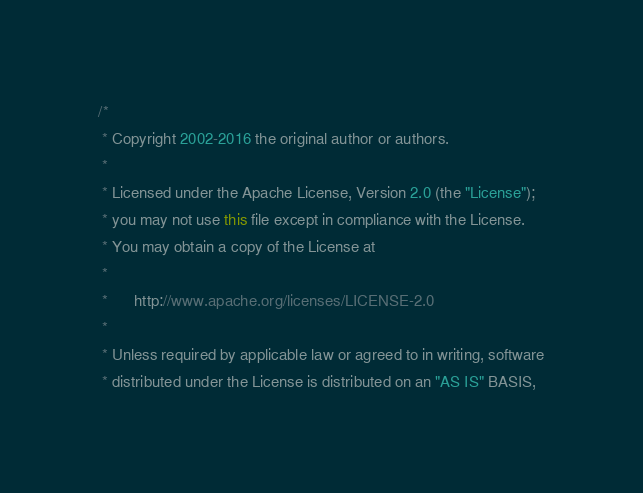Convert code to text. <code><loc_0><loc_0><loc_500><loc_500><_Java_>/*
 * Copyright 2002-2016 the original author or authors.
 *
 * Licensed under the Apache License, Version 2.0 (the "License");
 * you may not use this file except in compliance with the License.
 * You may obtain a copy of the License at
 *
 *      http://www.apache.org/licenses/LICENSE-2.0
 *
 * Unless required by applicable law or agreed to in writing, software
 * distributed under the License is distributed on an "AS IS" BASIS,</code> 